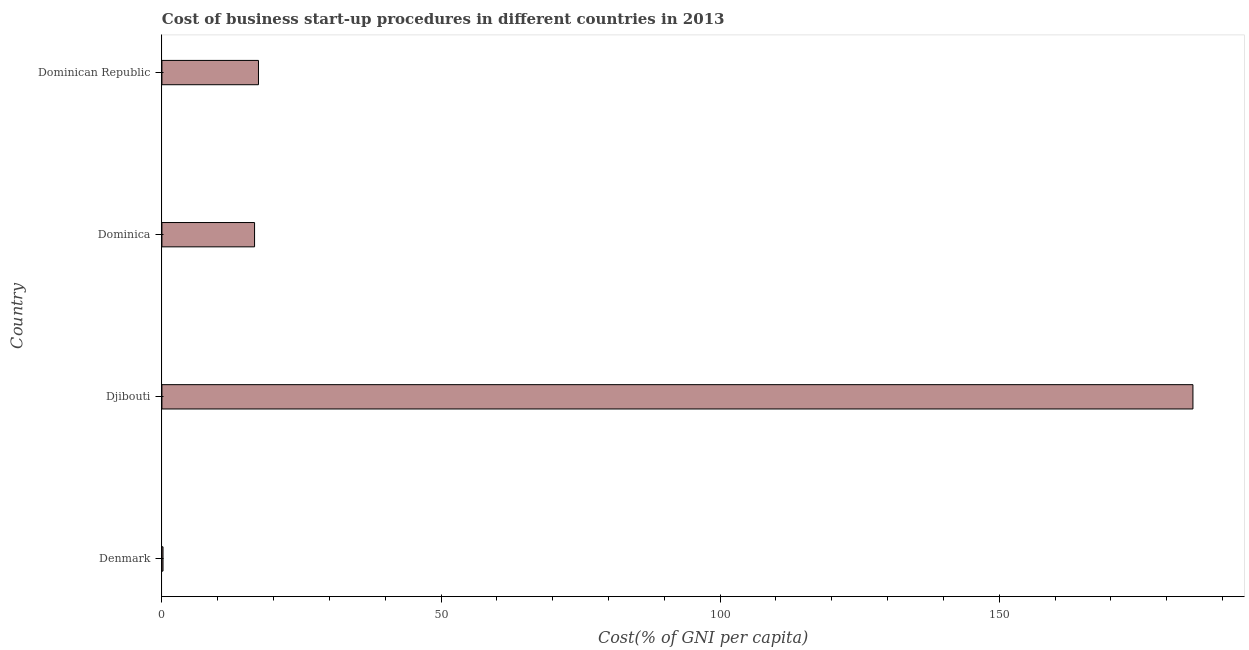Does the graph contain any zero values?
Your answer should be compact. No. What is the title of the graph?
Your response must be concise. Cost of business start-up procedures in different countries in 2013. What is the label or title of the X-axis?
Your response must be concise. Cost(% of GNI per capita). What is the cost of business startup procedures in Denmark?
Give a very brief answer. 0.2. Across all countries, what is the maximum cost of business startup procedures?
Your answer should be compact. 184.7. In which country was the cost of business startup procedures maximum?
Give a very brief answer. Djibouti. What is the sum of the cost of business startup procedures?
Provide a succinct answer. 218.8. What is the difference between the cost of business startup procedures in Denmark and Djibouti?
Offer a terse response. -184.5. What is the average cost of business startup procedures per country?
Ensure brevity in your answer.  54.7. What is the median cost of business startup procedures?
Offer a very short reply. 16.95. What is the ratio of the cost of business startup procedures in Denmark to that in Dominican Republic?
Give a very brief answer. 0.01. What is the difference between the highest and the second highest cost of business startup procedures?
Ensure brevity in your answer.  167.4. Is the sum of the cost of business startup procedures in Denmark and Dominican Republic greater than the maximum cost of business startup procedures across all countries?
Your response must be concise. No. What is the difference between the highest and the lowest cost of business startup procedures?
Offer a very short reply. 184.5. In how many countries, is the cost of business startup procedures greater than the average cost of business startup procedures taken over all countries?
Ensure brevity in your answer.  1. Are all the bars in the graph horizontal?
Provide a short and direct response. Yes. What is the difference between two consecutive major ticks on the X-axis?
Your response must be concise. 50. What is the Cost(% of GNI per capita) of Djibouti?
Your answer should be very brief. 184.7. What is the Cost(% of GNI per capita) of Dominican Republic?
Your answer should be compact. 17.3. What is the difference between the Cost(% of GNI per capita) in Denmark and Djibouti?
Your answer should be very brief. -184.5. What is the difference between the Cost(% of GNI per capita) in Denmark and Dominica?
Ensure brevity in your answer.  -16.4. What is the difference between the Cost(% of GNI per capita) in Denmark and Dominican Republic?
Ensure brevity in your answer.  -17.1. What is the difference between the Cost(% of GNI per capita) in Djibouti and Dominica?
Keep it short and to the point. 168.1. What is the difference between the Cost(% of GNI per capita) in Djibouti and Dominican Republic?
Offer a very short reply. 167.4. What is the difference between the Cost(% of GNI per capita) in Dominica and Dominican Republic?
Provide a short and direct response. -0.7. What is the ratio of the Cost(% of GNI per capita) in Denmark to that in Djibouti?
Give a very brief answer. 0. What is the ratio of the Cost(% of GNI per capita) in Denmark to that in Dominica?
Give a very brief answer. 0.01. What is the ratio of the Cost(% of GNI per capita) in Denmark to that in Dominican Republic?
Offer a very short reply. 0.01. What is the ratio of the Cost(% of GNI per capita) in Djibouti to that in Dominica?
Give a very brief answer. 11.13. What is the ratio of the Cost(% of GNI per capita) in Djibouti to that in Dominican Republic?
Give a very brief answer. 10.68. What is the ratio of the Cost(% of GNI per capita) in Dominica to that in Dominican Republic?
Offer a terse response. 0.96. 